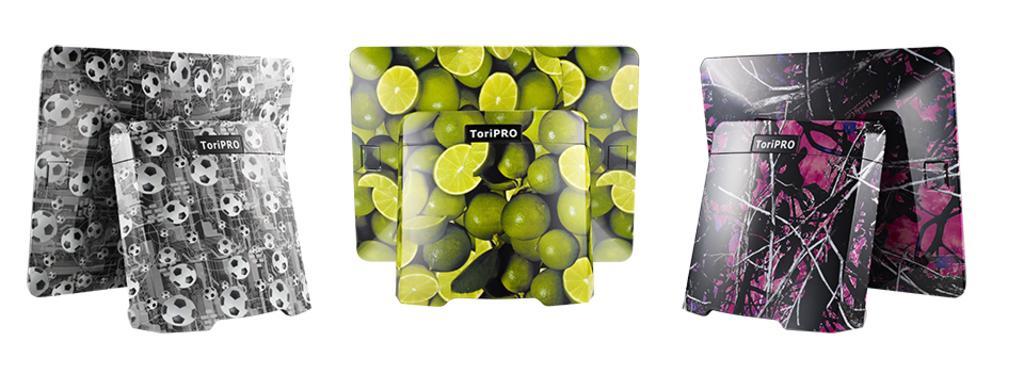How would you summarize this image in a sentence or two? In the image there are three different objects with different designs. 